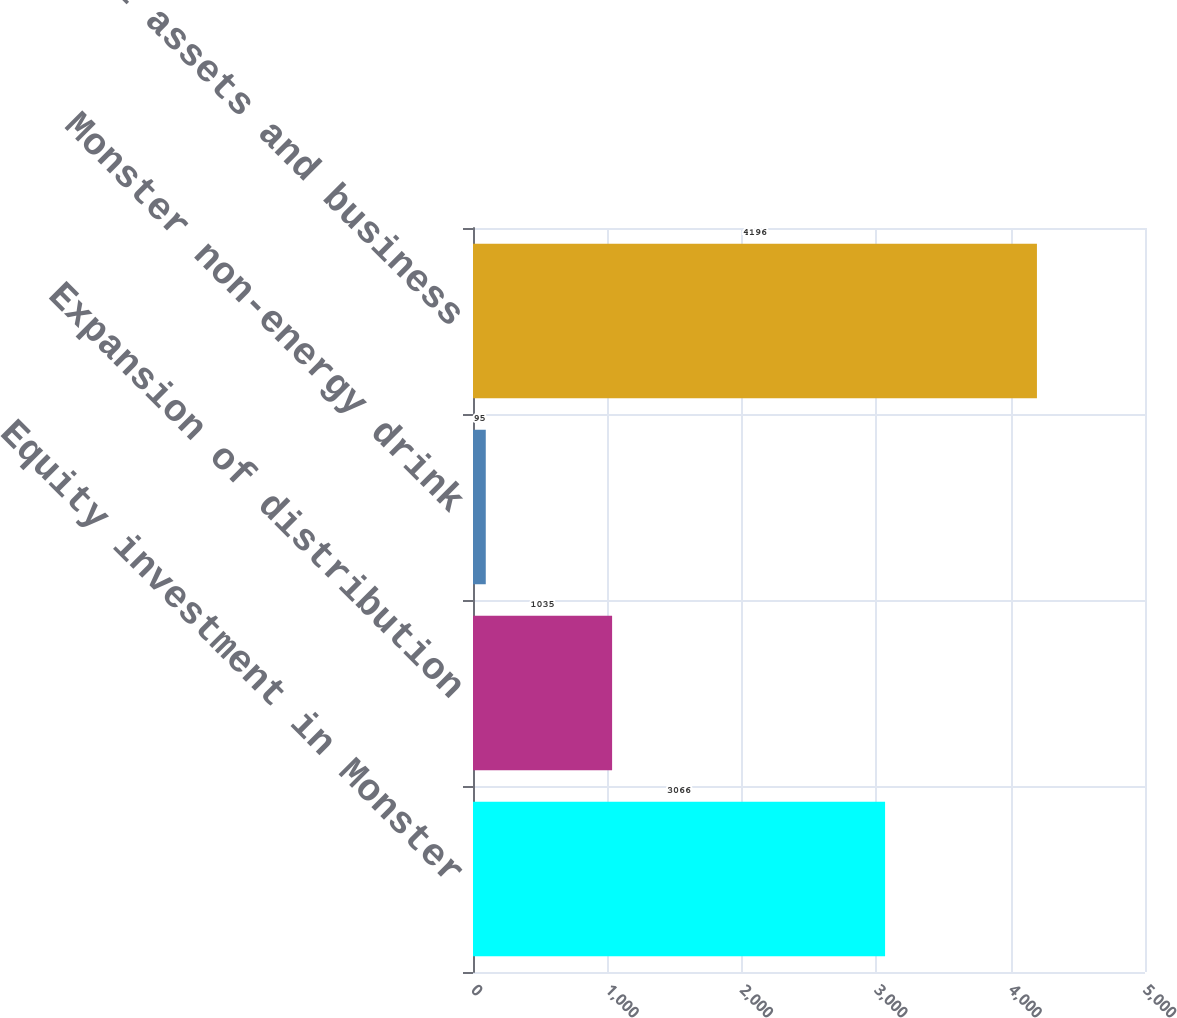<chart> <loc_0><loc_0><loc_500><loc_500><bar_chart><fcel>Equity investment in Monster<fcel>Expansion of distribution<fcel>Monster non-energy drink<fcel>Total assets and business<nl><fcel>3066<fcel>1035<fcel>95<fcel>4196<nl></chart> 